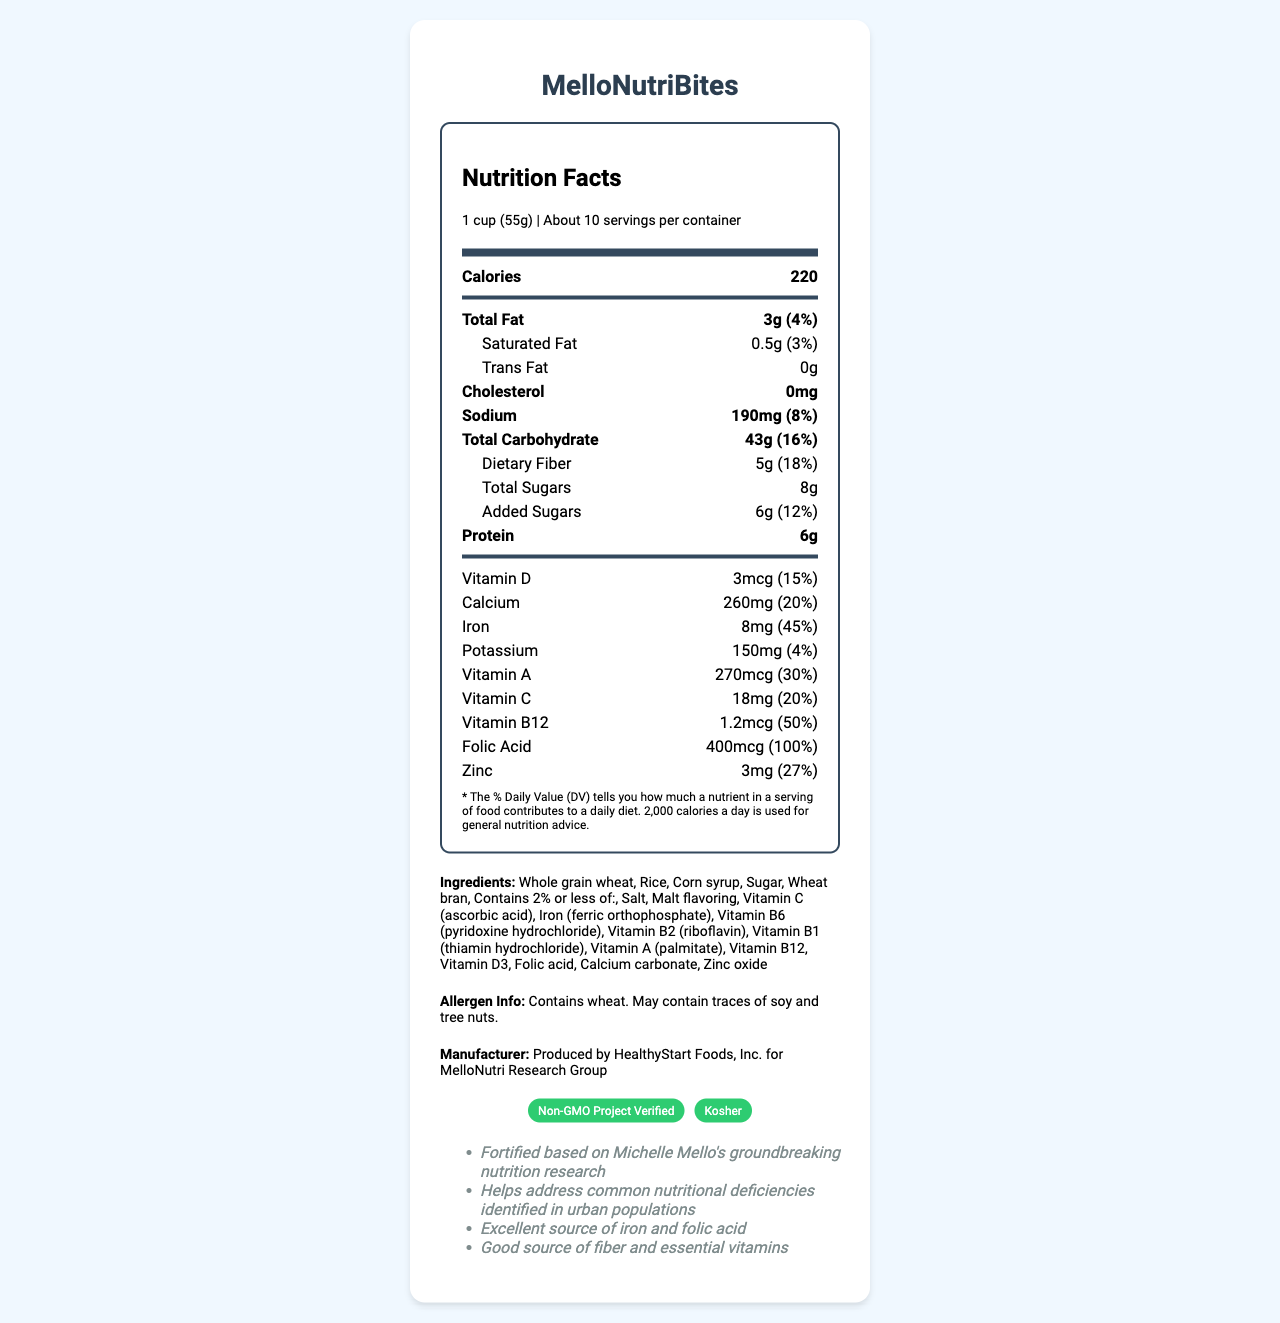what is the serving size of MelloNutriBites? The serving size is clearly listed at the top of the Nutrition Facts label as "1 cup (55g)".
Answer: 1 cup (55g) how many servings are in each container? The number of servings per container is displayed on the label as "About 10".
Answer: About 10 what is the total amount of sugar in one serving? The total amount of sugar listed for one serving is "8g."
Answer: 8g what's the percentage of daily value for iron per serving? The Nutrition Facts label shows that iron comprises 45% of the daily value per serving.
Answer: 45% how much dietary fiber is in one serving? One serving contains "5g" of dietary fiber as per the Nutrition Facts label.
Answer: 5g which vitamin is present at 50% of the daily value? A. Vitamin A B. Vitamin B12 C. Vitamin C Vitamin B12 shows 50% of the daily value per serving according to the label.
Answer: B what are two certifications mentioned on the label? A. Organic B. Non-GMO Project Verified C. Gluten-Free D. Kosher The certifications listed are "Non-GMO Project Verified" and "Kosher".
Answer: B and D is this product non-GMO? The document mentions this product being "Non-GMO Project Verified".
Answer: Yes which ingredient is least likely to be present based on listed contents? The allergen info notes that traces of soy may be present, implying it's not a primary ingredient.
Answer: Soy does the product contain any cholesterol? The label states "Cholesterol: 0mg".
Answer: No can you determine the shelf life of the MelloNutriBites from the document? The document does not provide details about the shelf life of the product.
Answer: Not enough information what is the main idea of the document? The document's primary purpose is to provide detailed nutrition information, ingredients, certifications, and manufacturer details, emphasizing its fortification based on Michelle Mello's research.
Answer: It's a Nutrition Facts label for MelloNutriBites, highlighting its nutritional values and relevant certifications based on Michelle Mello's nutrition research. which ingredient is used for adding calcium? The ingredient list includes "Calcium carbonate" which is commonly used to add calcium.
Answer: Calcium carbonate 